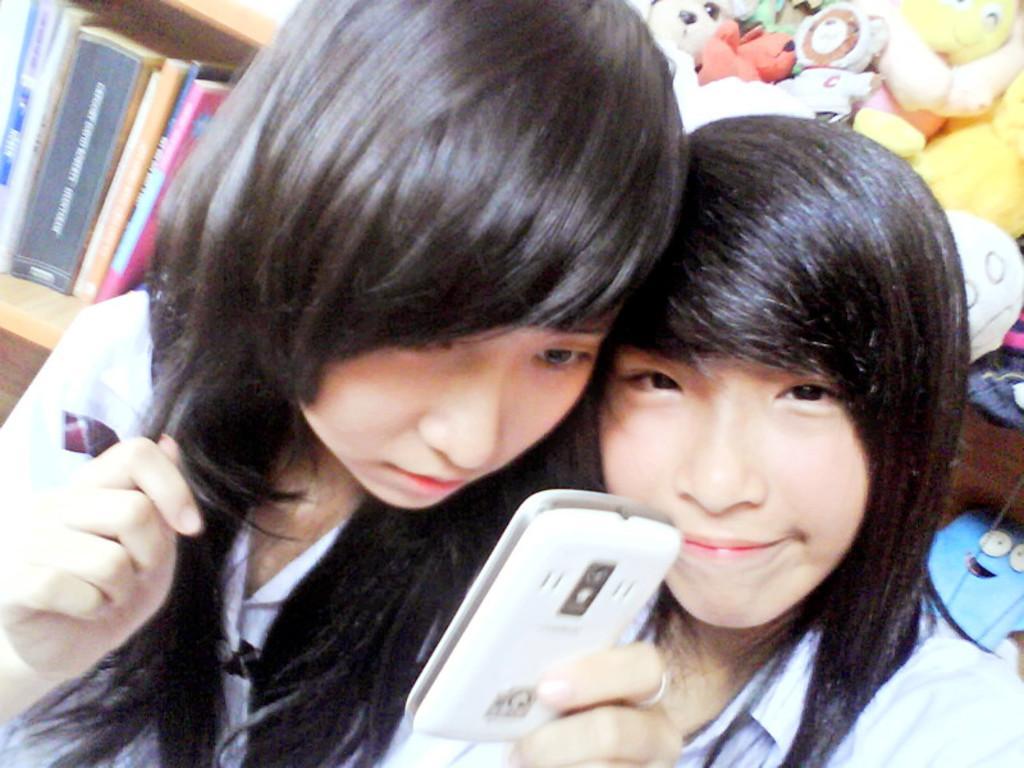How would you summarize this image in a sentence or two? In this pictures that two girls one of them is smiling and one of them is looking into the phone, in the background there are some some toys and they are some books kept in the Shell 